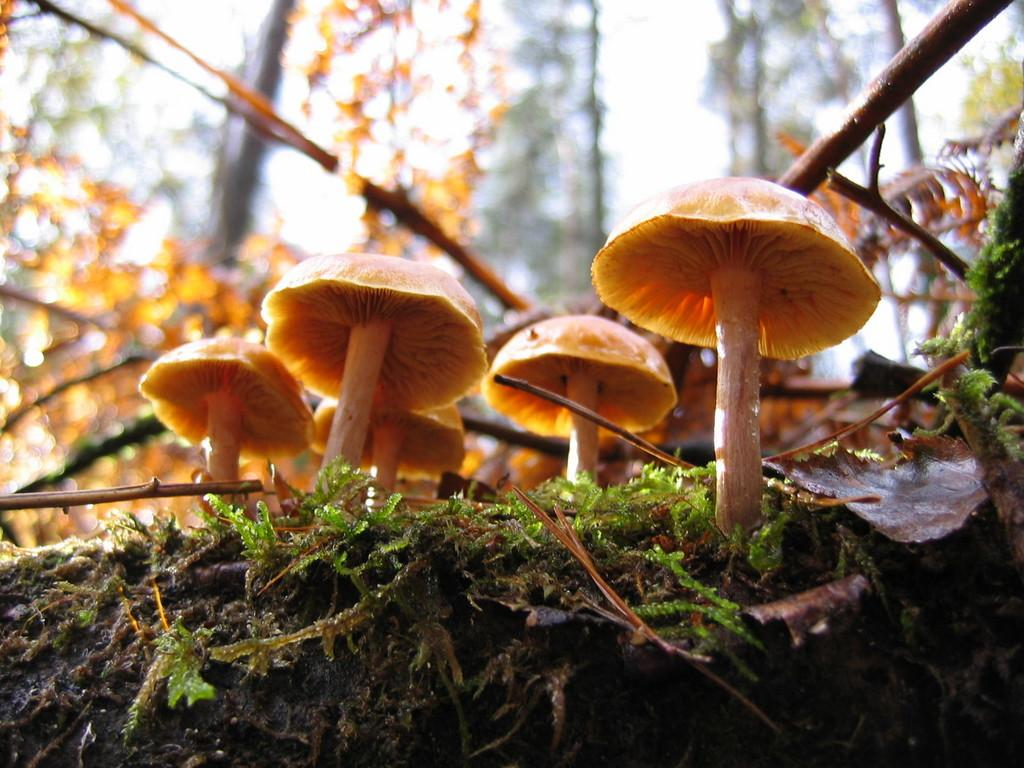What is the main subject of the image? The main subject of the image is mushrooms, which are located in the center of the image. Can you describe the background of the image? The background of the image is blurry. What type of cheese is being served by the ladybug in the image? There is no ladybug or cheese present in the image; it features mushrooms in the center and a blurry background. 